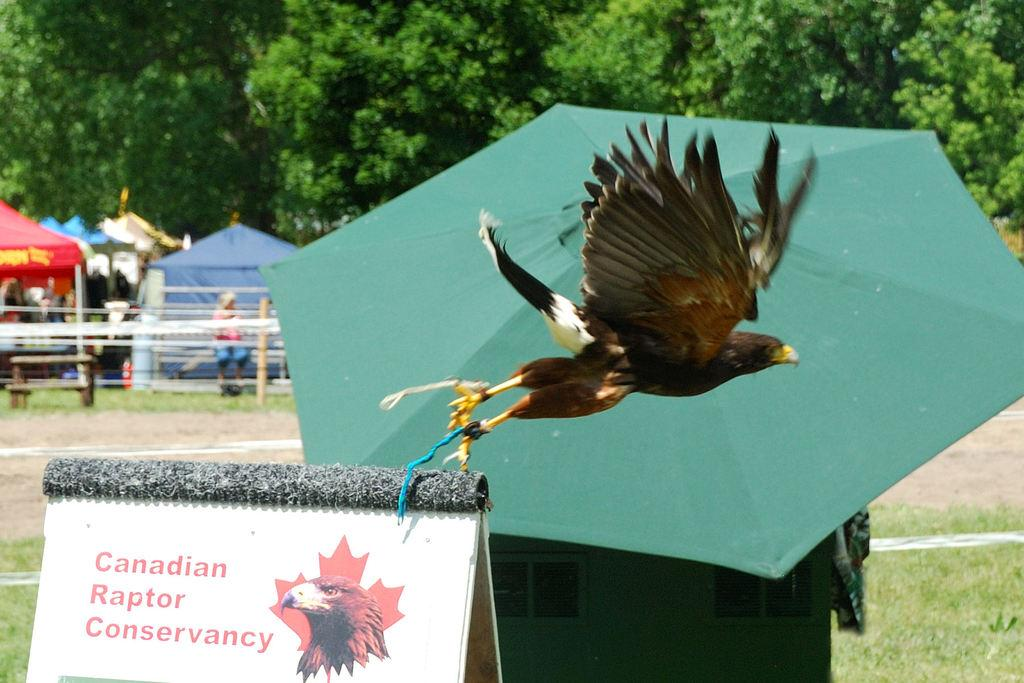What is the main object in the image? There is a board in the image. What type of animal can be seen in the image? There is a bird in the image. What is the bird holding in the image? The bird is holding an umbrella in the image. What type of shelter is visible in the image? There are tents in the image. What type of seating is present in the image? There is a bench in the image. How many persons are present in the image? There are persons in the image. What type of ground surface is visible in the image? There is grass visible in the image. What can be seen in the background of the image? There are trees in the background of the image. What type of crayon is being used by the bird to draw on the board in the image? There is no crayon present in the image, and the bird is holding an umbrella, not a crayon. What type of fuel is being used by the persons in the image to power their journey? There is no mention of a journey or fuel in the image; it simply shows a board, a bird, an umbrella, tents, a bench, persons, grass, and trees. 